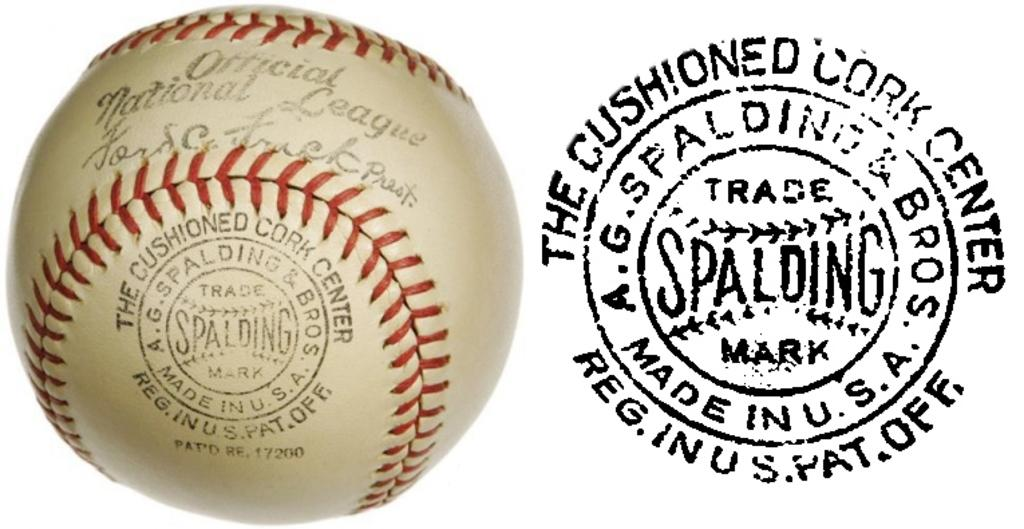What object is present in the image that is typically used for play or sports? There is a ball in the image. What is unique about the ball in the image? The ball has text on it. What other object can be seen in the image? There is a stamp in the image. How many pizzas are being served on the table in the image? There is no table or pizzas present in the image; it only features a ball with text and a stamp. What type of animal can be seen grazing in the background of the image? There are no animals present in the image; it only features a ball with text and a stamp. 